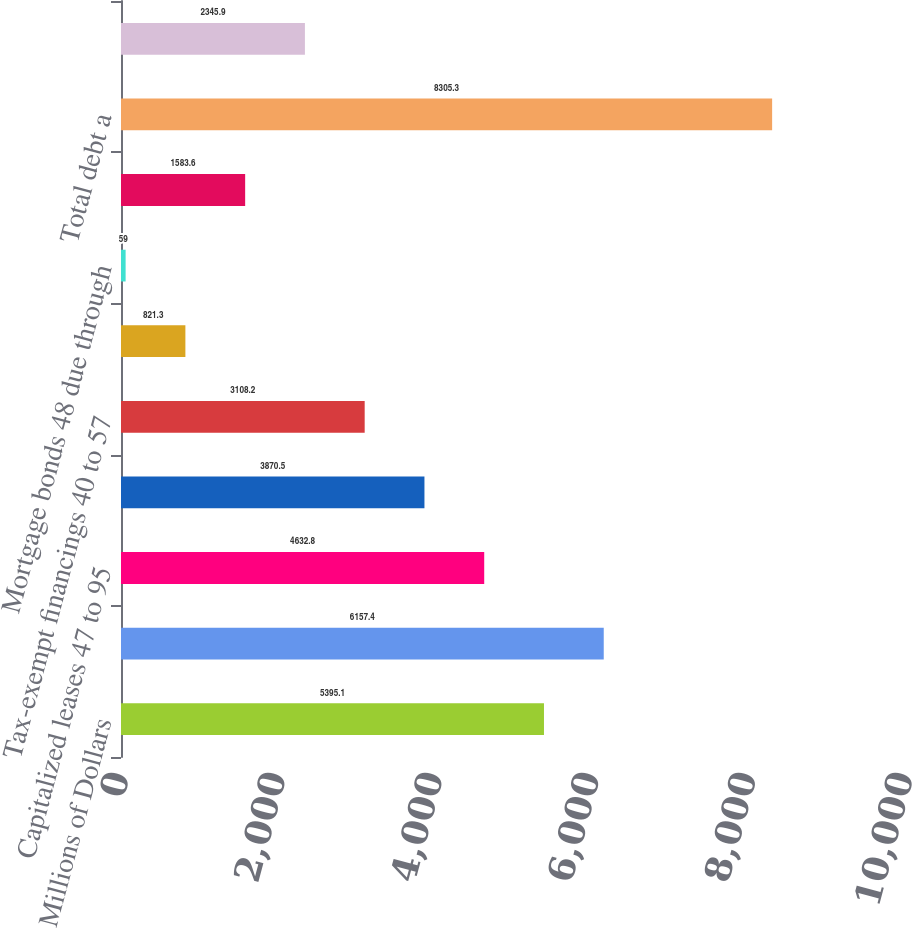Convert chart to OTSL. <chart><loc_0><loc_0><loc_500><loc_500><bar_chart><fcel>Millions of Dollars<fcel>Notes and debentures 30 to 79<fcel>Capitalized leases 47 to 95<fcel>Equipment obligations 62 to 81<fcel>Tax-exempt financings 40 to 57<fcel>Medium-term notes 92 to 100<fcel>Mortgage bonds 48 due through<fcel>Unamortized discount<fcel>Total debt a<fcel>Less current portion<nl><fcel>5395.1<fcel>6157.4<fcel>4632.8<fcel>3870.5<fcel>3108.2<fcel>821.3<fcel>59<fcel>1583.6<fcel>8305.3<fcel>2345.9<nl></chart> 